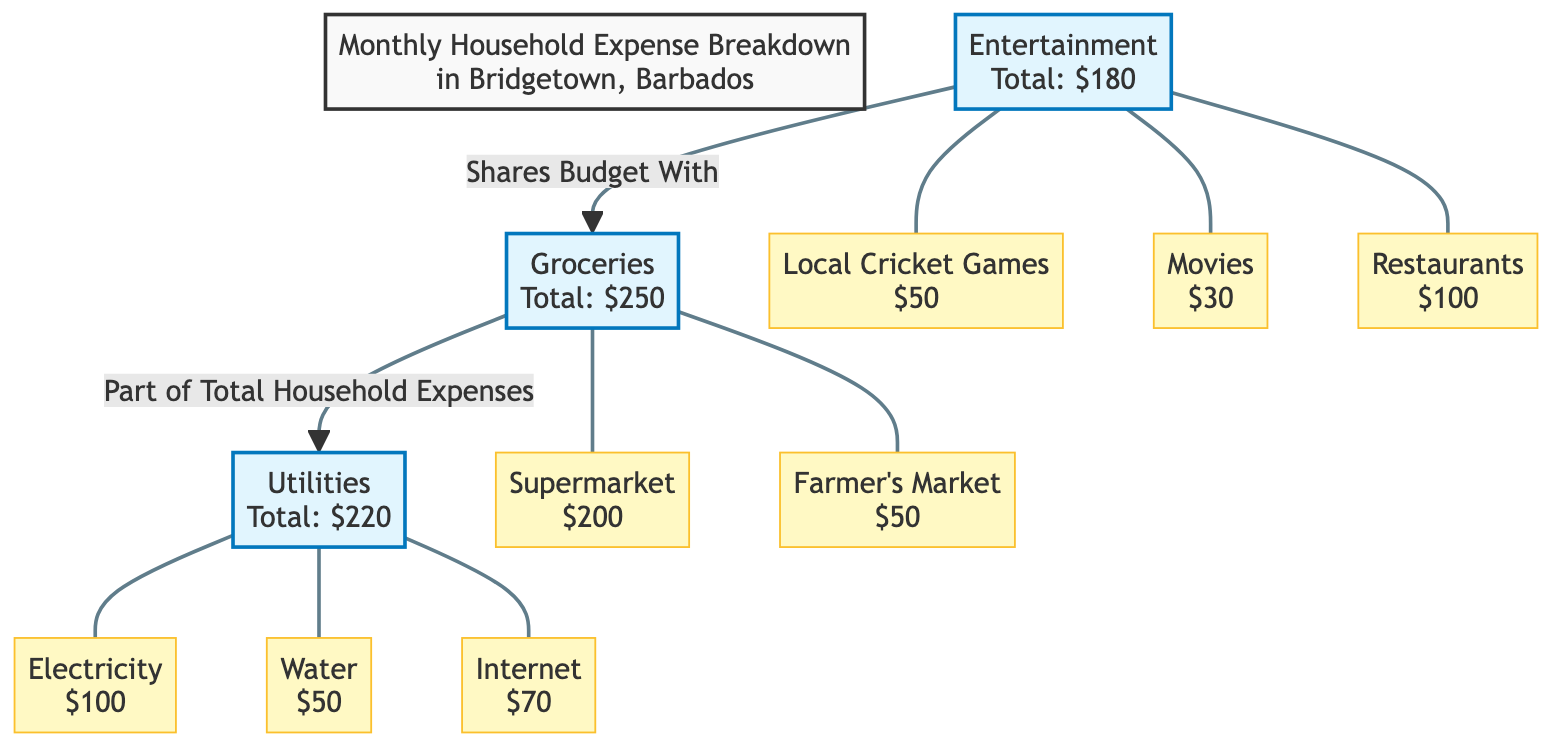What is the total amount spent on entertainment? The diagram shows 'Entertainment' with a total expense of $180 labeled.
Answer: $180 Which category has the highest expense? Comparing the total expenses for entertainment ($180), groceries ($250), and utilities ($220), groceries is the highest at $250.
Answer: Groceries How many types of entertainment expenses are listed? The entertainment category includes three specific expenses: cricket, movies, and restaurants. This can be counted directly from the diagram's details under entertainment.
Answer: 3 What is the total amount for utilities? The diagram specifies 'Utilities' with a total expense of $220, which is directly provided in the node.
Answer: $220 What is the expense for electricity under utilities? Within the utilities category, the diagram indicates electricity has a specific expense of $100. This detail is noted as part of the utilities node.
Answer: $100 How much do local cricket games contribute to the entertainment budget? The diagram specifically states that local cricket games contribute $50 to the entertainment budget, shown as a detail under the entertainment node.
Answer: $50 What percentage of the total household expenses is spent on groceries if the total is $650? Groceries total $250. To find the percentage, calculate (250/650)*100, which gives approximately 38.46%. This requires knowledge of the total expenses, which is inferred from the totals provided.
Answer: 38.46% Which detail has the lowest expense in the groceries category? The groceries category includes two expenses: supermarket ($200) and farmer's market ($50). Among these, the farmer's market at $50 is the lowest.
Answer: Farmer's Market What is the combined total of water and internet expenses? Water expense is $50 and internet expense is $70. To find the combined total, add these figures together: 50 + 70 = 120. This involves summation of the specific utility components from the diagram.
Answer: $120 